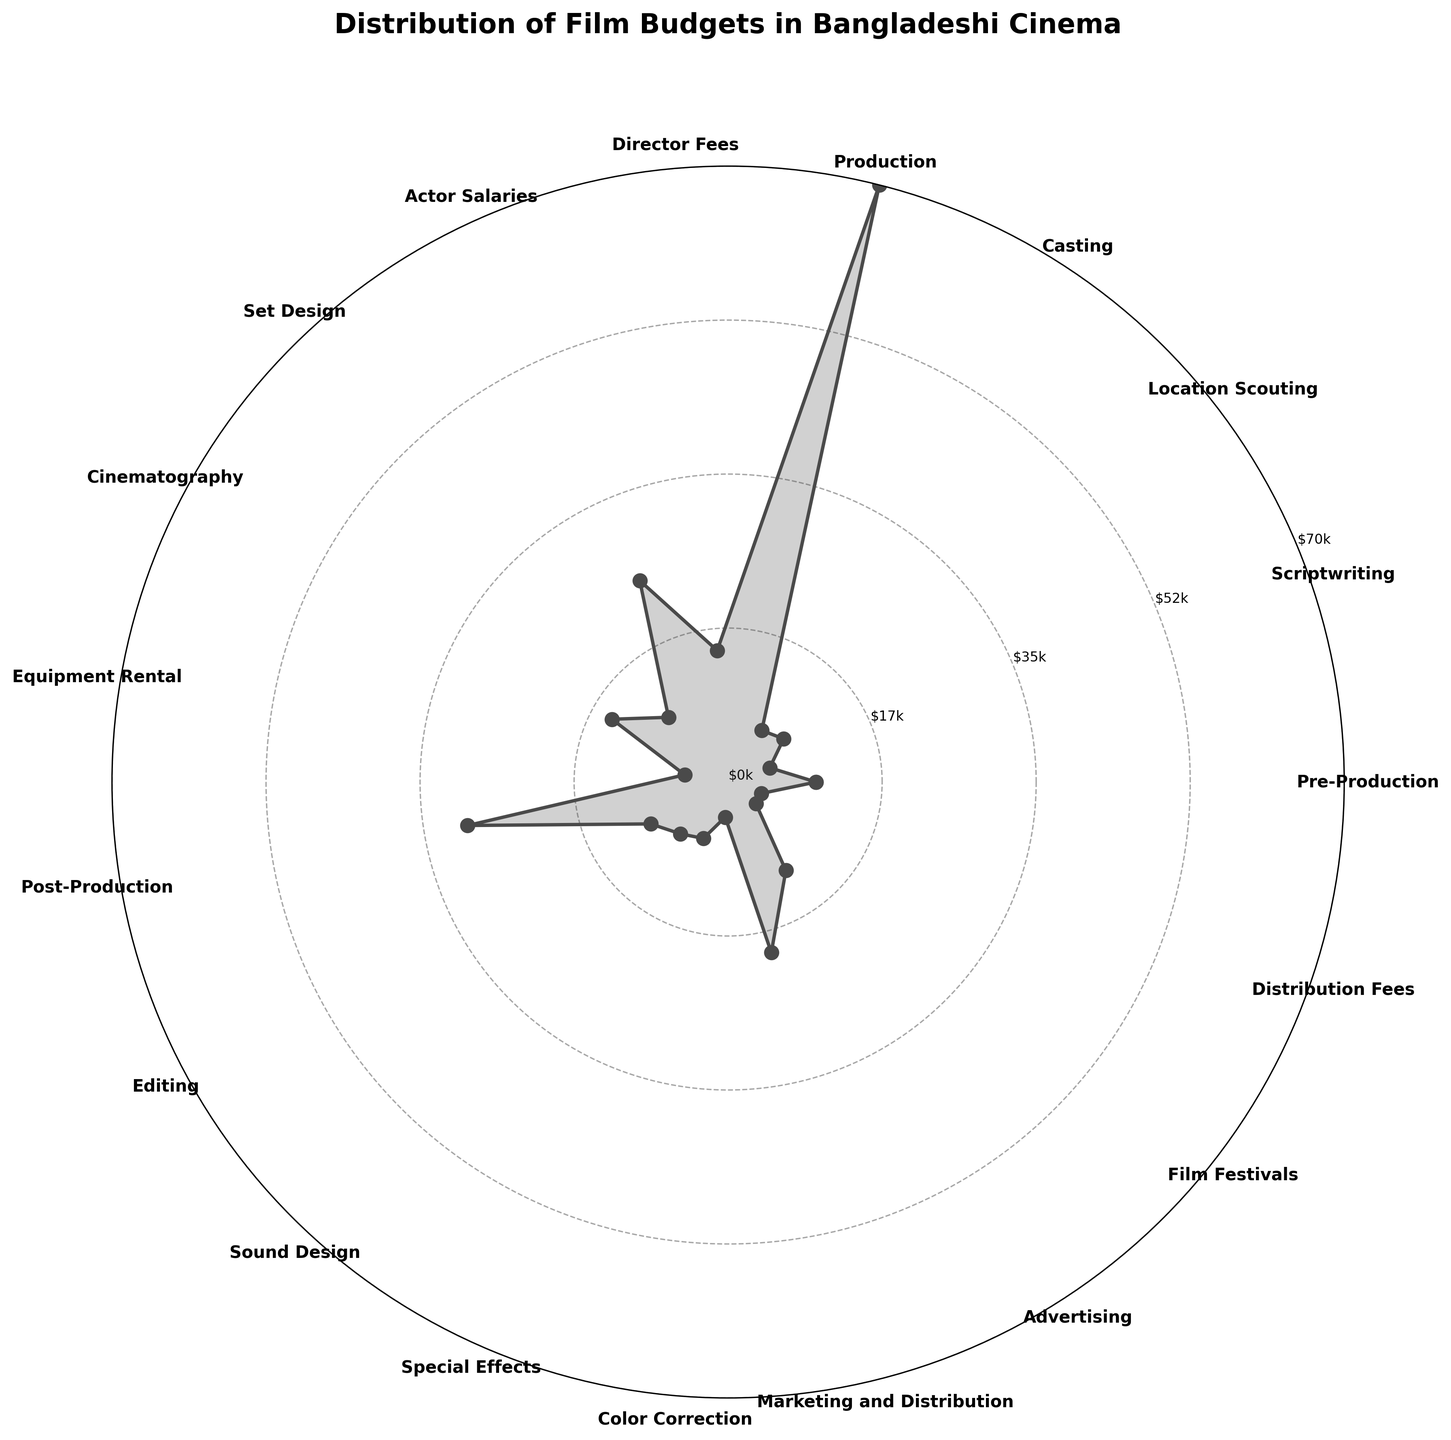What is the title of the plot? The title of the plot is usually found at the top of the figure. Here, it reads "Distribution of Film Budgets in Bangladeshi Cinema".
Answer: Distribution of Film Budgets in Bangladeshi Cinema Which expense category has the highest budget? By observing the polar plot, the category with the furthest point from the center has the highest budget. Here, "Production" extends the most outward.
Answer: Production What colors are used in the plot lines and fill area? The plot line and the fill area are mainly the same; the lines are solid, and the fill color is a shaded or transparent version of that color. They are gray (or grayscale color).
Answer: Gray What is the combined expense for Scriptwriting, Sound Design, and Special Effects? We need to sum up the amounts for these categories. Scriptwriting = $5,000, Sound Design = $8,000, Special Effects = $7,000. Therefore, $5,000 + $8,000 + $7,000 = $20,000.
Answer: $20,000 Which two categories have the smallest budgets? By looking at the plot and finding the two points closest to the center, we see that "Color Correction" and "Distribution Fees" are the smallest.
Answer: Color Correction and Distribution Fees How does the budget for Actor Salaries compare to Director Fees? The plot allows us to visually compare the distances from the center. Actor Salaries are $25,000, and Director Fees are $15,000. Hence, Actor Salaries have a higher budget than Director Fees.
Answer: Actor Salaries have a higher budget What is the total expense for pre-production activities (Pre-Production, Scriptwriting, Location Scouting, and Casting)? Add the budgets for Pre-Production = $10,000, Scriptwriting = $5,000, Location Scouting = $8,000, and Casting = $7,000. So, $10,000 + $5,000 + $8,000 + $7,000 = $30,000.
Answer: $30,000 Which categories are labeled in the inner-most radial ticks? The categories closest to the center, falling within the smallest radial circle, are identified by inspecting the labels and their corresponding positions. Distribution Fees and Color Correction are labeled there.
Answer: Distribution Fees and Color Correction What is the difference between the budgets for Post-Production and Marketing and Distribution? Post-Production has a budget of $30,000 and Marketing and Distribution has $20,000. The difference is $30,000 - $20,000 = $10,000.
Answer: $10,000 Which expenses fall between the $5k and $10k budgets? Observing the figure, we see that Scriptwriting ($5k), Set Design ($10k), Equipment Rental ($5k), Editing ($10k), Sound Design ($8k), Special Effects ($7k), and Film Festivals ($4k) fall within or very close to this range.
Answer: Scriptwriting, Set Design, Equipment Rental, Editing, Sound Design, Special Effects, and Film Festivals 